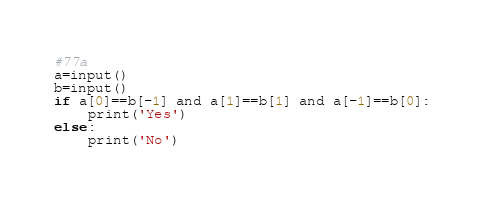<code> <loc_0><loc_0><loc_500><loc_500><_Python_>#77a
a=input()
b=input()
if a[0]==b[-1] and a[1]==b[1] and a[-1]==b[0]:
    print('Yes')
else:
    print('No')</code> 